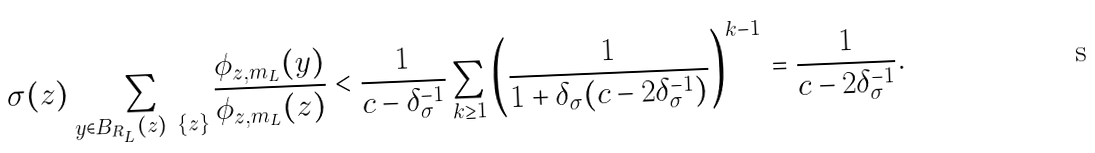Convert formula to latex. <formula><loc_0><loc_0><loc_500><loc_500>\sigma ( z ) \sum _ { y \in B _ { R _ { L } } ( z ) \ \{ z \} } \frac { \phi _ { z , m _ { L } } ( y ) } { \phi _ { z , m _ { L } } ( z ) } < \frac { 1 } { c - \delta _ { \sigma } ^ { - 1 } } \sum _ { k \geq 1 } \left ( \frac { 1 } { 1 + \delta _ { \sigma } ( c - 2 \delta _ { \sigma } ^ { - 1 } ) } \right ) ^ { k - 1 } = \frac { 1 } { c - 2 \delta _ { \sigma } ^ { - 1 } } .</formula> 